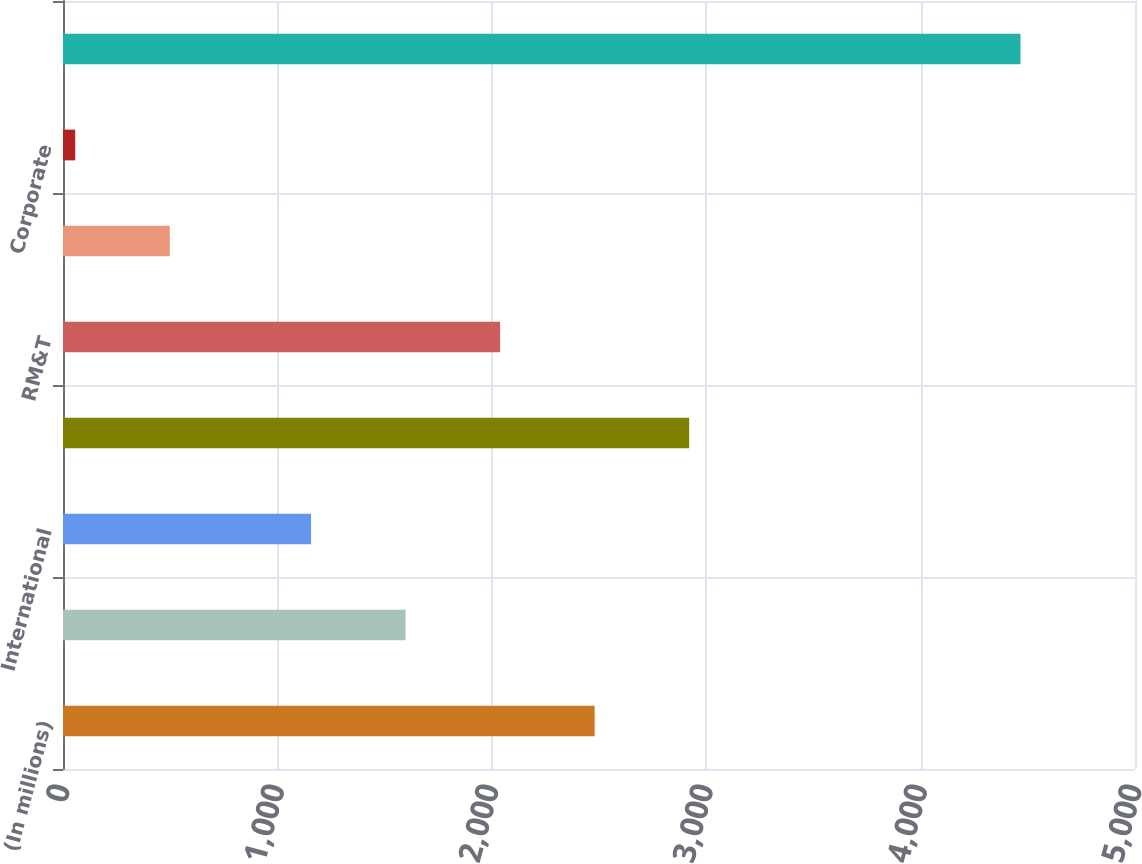<chart> <loc_0><loc_0><loc_500><loc_500><bar_chart><fcel>(In millions)<fcel>United States<fcel>International<fcel>Total E&P<fcel>RM&T<fcel>IG<fcel>Corporate<fcel>Total<nl><fcel>2479.7<fcel>1597.9<fcel>1157<fcel>2920.6<fcel>2038.8<fcel>497.9<fcel>57<fcel>4466<nl></chart> 